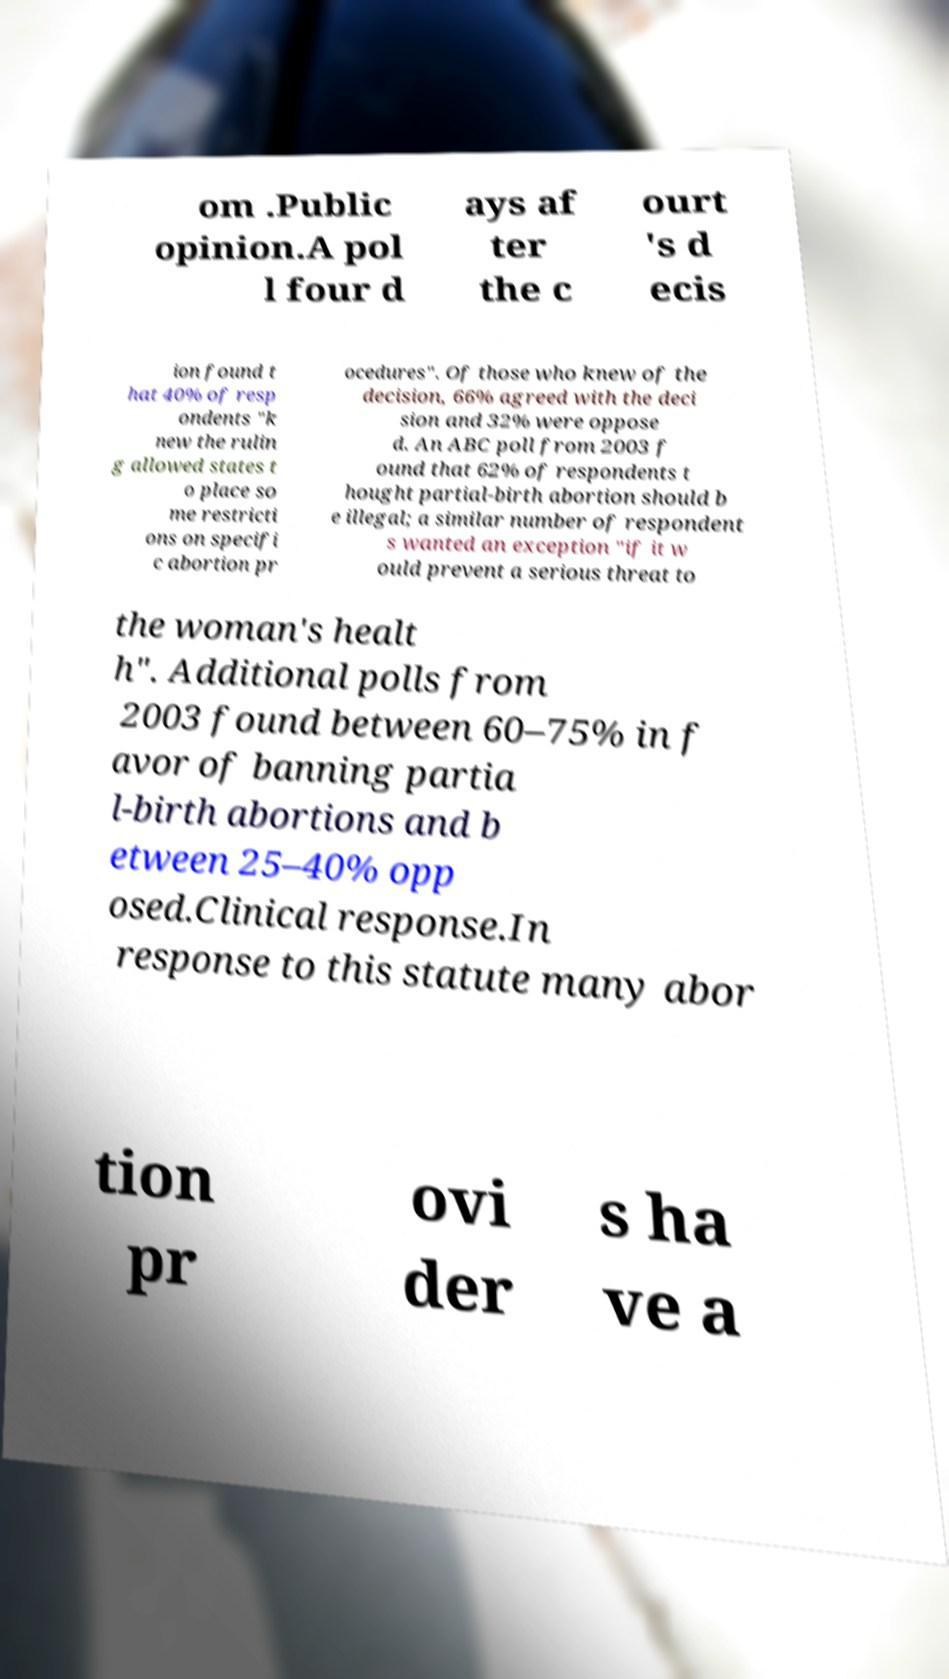For documentation purposes, I need the text within this image transcribed. Could you provide that? om .Public opinion.A pol l four d ays af ter the c ourt 's d ecis ion found t hat 40% of resp ondents "k new the rulin g allowed states t o place so me restricti ons on specifi c abortion pr ocedures". Of those who knew of the decision, 66% agreed with the deci sion and 32% were oppose d. An ABC poll from 2003 f ound that 62% of respondents t hought partial-birth abortion should b e illegal; a similar number of respondent s wanted an exception "if it w ould prevent a serious threat to the woman's healt h". Additional polls from 2003 found between 60–75% in f avor of banning partia l-birth abortions and b etween 25–40% opp osed.Clinical response.In response to this statute many abor tion pr ovi der s ha ve a 